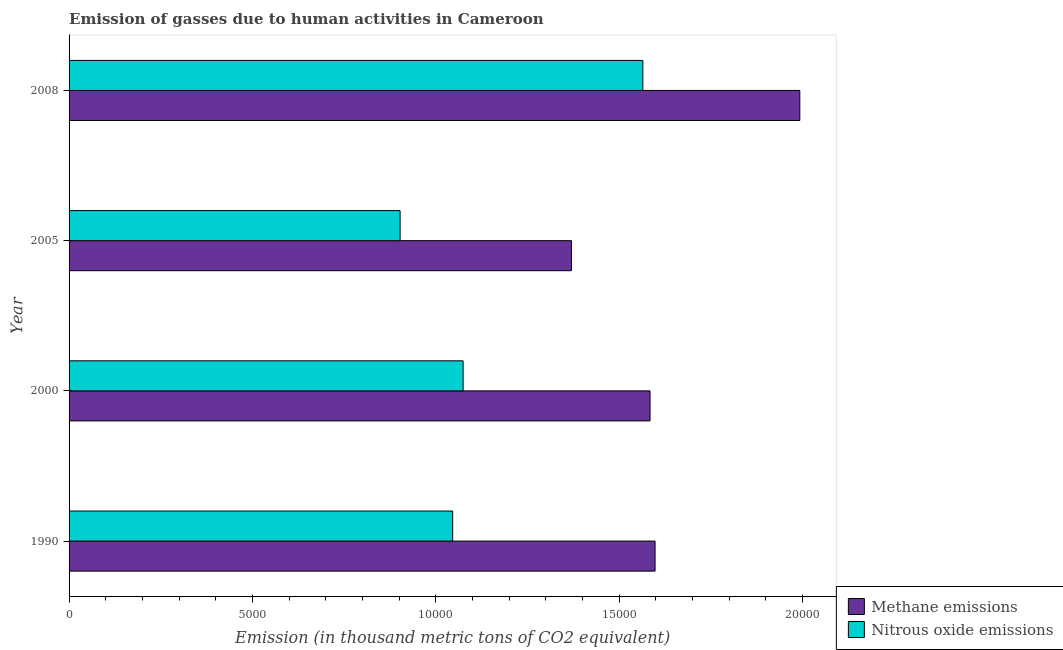Are the number of bars per tick equal to the number of legend labels?
Your answer should be very brief. Yes. Are the number of bars on each tick of the Y-axis equal?
Provide a short and direct response. Yes. How many bars are there on the 3rd tick from the top?
Your answer should be very brief. 2. What is the label of the 3rd group of bars from the top?
Make the answer very short. 2000. In how many cases, is the number of bars for a given year not equal to the number of legend labels?
Your answer should be very brief. 0. What is the amount of methane emissions in 2008?
Your response must be concise. 1.99e+04. Across all years, what is the maximum amount of methane emissions?
Your answer should be compact. 1.99e+04. Across all years, what is the minimum amount of methane emissions?
Offer a terse response. 1.37e+04. What is the total amount of methane emissions in the graph?
Offer a terse response. 6.54e+04. What is the difference between the amount of nitrous oxide emissions in 1990 and that in 2000?
Your answer should be very brief. -285.5. What is the difference between the amount of nitrous oxide emissions in 2000 and the amount of methane emissions in 2008?
Ensure brevity in your answer.  -9181.5. What is the average amount of methane emissions per year?
Provide a short and direct response. 1.64e+04. In the year 1990, what is the difference between the amount of methane emissions and amount of nitrous oxide emissions?
Keep it short and to the point. 5519.8. In how many years, is the amount of methane emissions greater than 12000 thousand metric tons?
Offer a very short reply. 4. What is the ratio of the amount of methane emissions in 2000 to that in 2008?
Keep it short and to the point. 0.8. Is the amount of nitrous oxide emissions in 2005 less than that in 2008?
Your answer should be very brief. Yes. What is the difference between the highest and the second highest amount of methane emissions?
Offer a very short reply. 3947.2. What is the difference between the highest and the lowest amount of nitrous oxide emissions?
Offer a very short reply. 6619.5. In how many years, is the amount of methane emissions greater than the average amount of methane emissions taken over all years?
Ensure brevity in your answer.  1. What does the 1st bar from the top in 2000 represents?
Give a very brief answer. Nitrous oxide emissions. What does the 1st bar from the bottom in 2008 represents?
Ensure brevity in your answer.  Methane emissions. How many bars are there?
Ensure brevity in your answer.  8. How many years are there in the graph?
Ensure brevity in your answer.  4. Does the graph contain any zero values?
Keep it short and to the point. No. How are the legend labels stacked?
Offer a very short reply. Vertical. What is the title of the graph?
Provide a succinct answer. Emission of gasses due to human activities in Cameroon. Does "Foreign Liabilities" appear as one of the legend labels in the graph?
Ensure brevity in your answer.  No. What is the label or title of the X-axis?
Provide a succinct answer. Emission (in thousand metric tons of CO2 equivalent). What is the label or title of the Y-axis?
Give a very brief answer. Year. What is the Emission (in thousand metric tons of CO2 equivalent) in Methane emissions in 1990?
Provide a short and direct response. 1.60e+04. What is the Emission (in thousand metric tons of CO2 equivalent) of Nitrous oxide emissions in 1990?
Offer a terse response. 1.05e+04. What is the Emission (in thousand metric tons of CO2 equivalent) of Methane emissions in 2000?
Provide a succinct answer. 1.58e+04. What is the Emission (in thousand metric tons of CO2 equivalent) of Nitrous oxide emissions in 2000?
Your answer should be very brief. 1.07e+04. What is the Emission (in thousand metric tons of CO2 equivalent) in Methane emissions in 2005?
Make the answer very short. 1.37e+04. What is the Emission (in thousand metric tons of CO2 equivalent) of Nitrous oxide emissions in 2005?
Offer a terse response. 9027.2. What is the Emission (in thousand metric tons of CO2 equivalent) of Methane emissions in 2008?
Keep it short and to the point. 1.99e+04. What is the Emission (in thousand metric tons of CO2 equivalent) in Nitrous oxide emissions in 2008?
Your answer should be compact. 1.56e+04. Across all years, what is the maximum Emission (in thousand metric tons of CO2 equivalent) of Methane emissions?
Provide a succinct answer. 1.99e+04. Across all years, what is the maximum Emission (in thousand metric tons of CO2 equivalent) of Nitrous oxide emissions?
Ensure brevity in your answer.  1.56e+04. Across all years, what is the minimum Emission (in thousand metric tons of CO2 equivalent) in Methane emissions?
Provide a succinct answer. 1.37e+04. Across all years, what is the minimum Emission (in thousand metric tons of CO2 equivalent) of Nitrous oxide emissions?
Give a very brief answer. 9027.2. What is the total Emission (in thousand metric tons of CO2 equivalent) in Methane emissions in the graph?
Offer a terse response. 6.54e+04. What is the total Emission (in thousand metric tons of CO2 equivalent) of Nitrous oxide emissions in the graph?
Your answer should be compact. 4.59e+04. What is the difference between the Emission (in thousand metric tons of CO2 equivalent) of Methane emissions in 1990 and that in 2000?
Ensure brevity in your answer.  137.2. What is the difference between the Emission (in thousand metric tons of CO2 equivalent) in Nitrous oxide emissions in 1990 and that in 2000?
Offer a terse response. -285.5. What is the difference between the Emission (in thousand metric tons of CO2 equivalent) in Methane emissions in 1990 and that in 2005?
Your answer should be compact. 2280.5. What is the difference between the Emission (in thousand metric tons of CO2 equivalent) of Nitrous oxide emissions in 1990 and that in 2005?
Offer a terse response. 1433.1. What is the difference between the Emission (in thousand metric tons of CO2 equivalent) of Methane emissions in 1990 and that in 2008?
Offer a very short reply. -3947.2. What is the difference between the Emission (in thousand metric tons of CO2 equivalent) of Nitrous oxide emissions in 1990 and that in 2008?
Keep it short and to the point. -5186.4. What is the difference between the Emission (in thousand metric tons of CO2 equivalent) in Methane emissions in 2000 and that in 2005?
Offer a very short reply. 2143.3. What is the difference between the Emission (in thousand metric tons of CO2 equivalent) in Nitrous oxide emissions in 2000 and that in 2005?
Give a very brief answer. 1718.6. What is the difference between the Emission (in thousand metric tons of CO2 equivalent) in Methane emissions in 2000 and that in 2008?
Your answer should be compact. -4084.4. What is the difference between the Emission (in thousand metric tons of CO2 equivalent) in Nitrous oxide emissions in 2000 and that in 2008?
Keep it short and to the point. -4900.9. What is the difference between the Emission (in thousand metric tons of CO2 equivalent) in Methane emissions in 2005 and that in 2008?
Offer a terse response. -6227.7. What is the difference between the Emission (in thousand metric tons of CO2 equivalent) in Nitrous oxide emissions in 2005 and that in 2008?
Provide a succinct answer. -6619.5. What is the difference between the Emission (in thousand metric tons of CO2 equivalent) of Methane emissions in 1990 and the Emission (in thousand metric tons of CO2 equivalent) of Nitrous oxide emissions in 2000?
Keep it short and to the point. 5234.3. What is the difference between the Emission (in thousand metric tons of CO2 equivalent) of Methane emissions in 1990 and the Emission (in thousand metric tons of CO2 equivalent) of Nitrous oxide emissions in 2005?
Keep it short and to the point. 6952.9. What is the difference between the Emission (in thousand metric tons of CO2 equivalent) of Methane emissions in 1990 and the Emission (in thousand metric tons of CO2 equivalent) of Nitrous oxide emissions in 2008?
Give a very brief answer. 333.4. What is the difference between the Emission (in thousand metric tons of CO2 equivalent) in Methane emissions in 2000 and the Emission (in thousand metric tons of CO2 equivalent) in Nitrous oxide emissions in 2005?
Provide a succinct answer. 6815.7. What is the difference between the Emission (in thousand metric tons of CO2 equivalent) in Methane emissions in 2000 and the Emission (in thousand metric tons of CO2 equivalent) in Nitrous oxide emissions in 2008?
Your response must be concise. 196.2. What is the difference between the Emission (in thousand metric tons of CO2 equivalent) of Methane emissions in 2005 and the Emission (in thousand metric tons of CO2 equivalent) of Nitrous oxide emissions in 2008?
Your response must be concise. -1947.1. What is the average Emission (in thousand metric tons of CO2 equivalent) of Methane emissions per year?
Provide a succinct answer. 1.64e+04. What is the average Emission (in thousand metric tons of CO2 equivalent) in Nitrous oxide emissions per year?
Give a very brief answer. 1.15e+04. In the year 1990, what is the difference between the Emission (in thousand metric tons of CO2 equivalent) of Methane emissions and Emission (in thousand metric tons of CO2 equivalent) of Nitrous oxide emissions?
Provide a succinct answer. 5519.8. In the year 2000, what is the difference between the Emission (in thousand metric tons of CO2 equivalent) in Methane emissions and Emission (in thousand metric tons of CO2 equivalent) in Nitrous oxide emissions?
Provide a succinct answer. 5097.1. In the year 2005, what is the difference between the Emission (in thousand metric tons of CO2 equivalent) of Methane emissions and Emission (in thousand metric tons of CO2 equivalent) of Nitrous oxide emissions?
Offer a terse response. 4672.4. In the year 2008, what is the difference between the Emission (in thousand metric tons of CO2 equivalent) of Methane emissions and Emission (in thousand metric tons of CO2 equivalent) of Nitrous oxide emissions?
Provide a succinct answer. 4280.6. What is the ratio of the Emission (in thousand metric tons of CO2 equivalent) in Methane emissions in 1990 to that in 2000?
Offer a terse response. 1.01. What is the ratio of the Emission (in thousand metric tons of CO2 equivalent) in Nitrous oxide emissions in 1990 to that in 2000?
Provide a succinct answer. 0.97. What is the ratio of the Emission (in thousand metric tons of CO2 equivalent) in Methane emissions in 1990 to that in 2005?
Provide a short and direct response. 1.17. What is the ratio of the Emission (in thousand metric tons of CO2 equivalent) in Nitrous oxide emissions in 1990 to that in 2005?
Ensure brevity in your answer.  1.16. What is the ratio of the Emission (in thousand metric tons of CO2 equivalent) of Methane emissions in 1990 to that in 2008?
Provide a succinct answer. 0.8. What is the ratio of the Emission (in thousand metric tons of CO2 equivalent) of Nitrous oxide emissions in 1990 to that in 2008?
Your answer should be very brief. 0.67. What is the ratio of the Emission (in thousand metric tons of CO2 equivalent) of Methane emissions in 2000 to that in 2005?
Offer a very short reply. 1.16. What is the ratio of the Emission (in thousand metric tons of CO2 equivalent) in Nitrous oxide emissions in 2000 to that in 2005?
Offer a very short reply. 1.19. What is the ratio of the Emission (in thousand metric tons of CO2 equivalent) in Methane emissions in 2000 to that in 2008?
Keep it short and to the point. 0.8. What is the ratio of the Emission (in thousand metric tons of CO2 equivalent) in Nitrous oxide emissions in 2000 to that in 2008?
Offer a terse response. 0.69. What is the ratio of the Emission (in thousand metric tons of CO2 equivalent) of Methane emissions in 2005 to that in 2008?
Give a very brief answer. 0.69. What is the ratio of the Emission (in thousand metric tons of CO2 equivalent) of Nitrous oxide emissions in 2005 to that in 2008?
Your response must be concise. 0.58. What is the difference between the highest and the second highest Emission (in thousand metric tons of CO2 equivalent) of Methane emissions?
Ensure brevity in your answer.  3947.2. What is the difference between the highest and the second highest Emission (in thousand metric tons of CO2 equivalent) in Nitrous oxide emissions?
Make the answer very short. 4900.9. What is the difference between the highest and the lowest Emission (in thousand metric tons of CO2 equivalent) in Methane emissions?
Offer a very short reply. 6227.7. What is the difference between the highest and the lowest Emission (in thousand metric tons of CO2 equivalent) in Nitrous oxide emissions?
Give a very brief answer. 6619.5. 